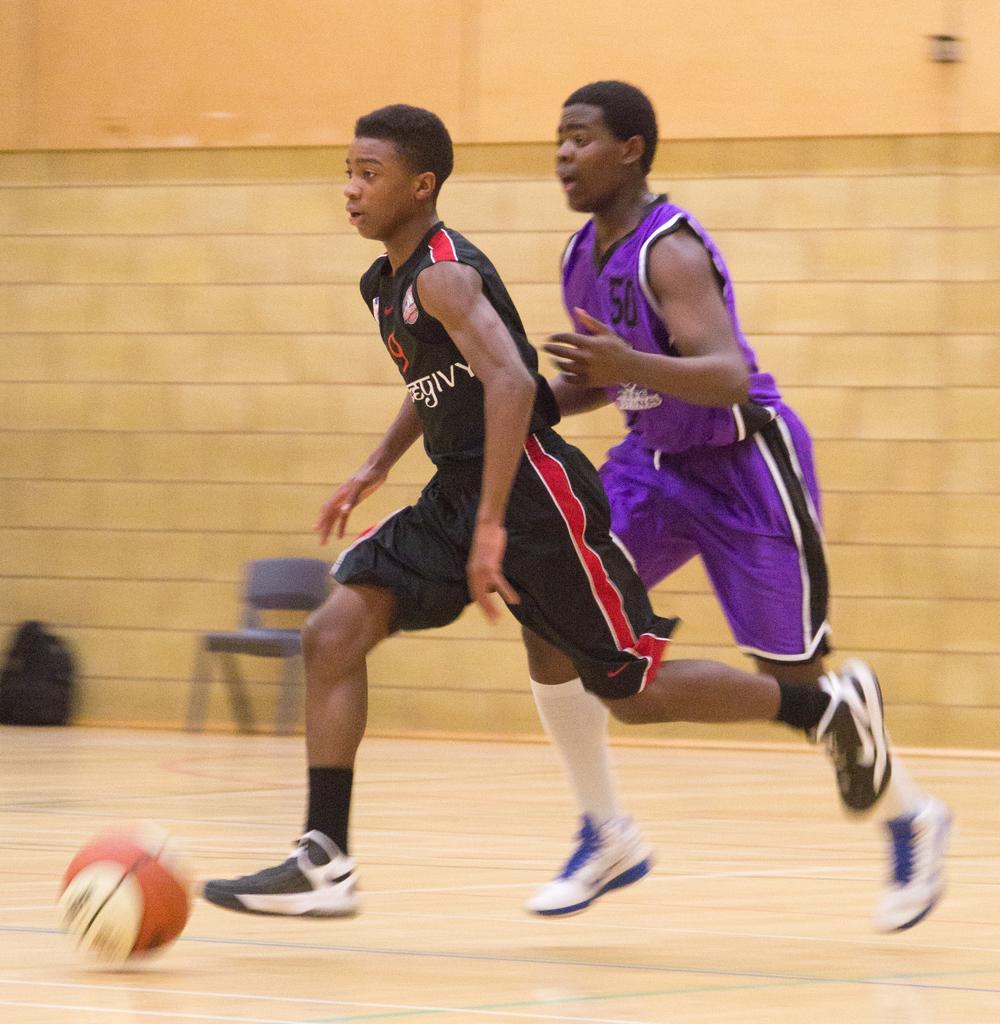Could you give a brief overview of what you see in this image? In the image the boy in the front in black dress running on the floor with foot ball in front of him and another boy in purple dress running on the right side, behind them there is a wall with chair in front of it. 